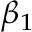Convert formula to latex. <formula><loc_0><loc_0><loc_500><loc_500>\beta _ { 1 }</formula> 